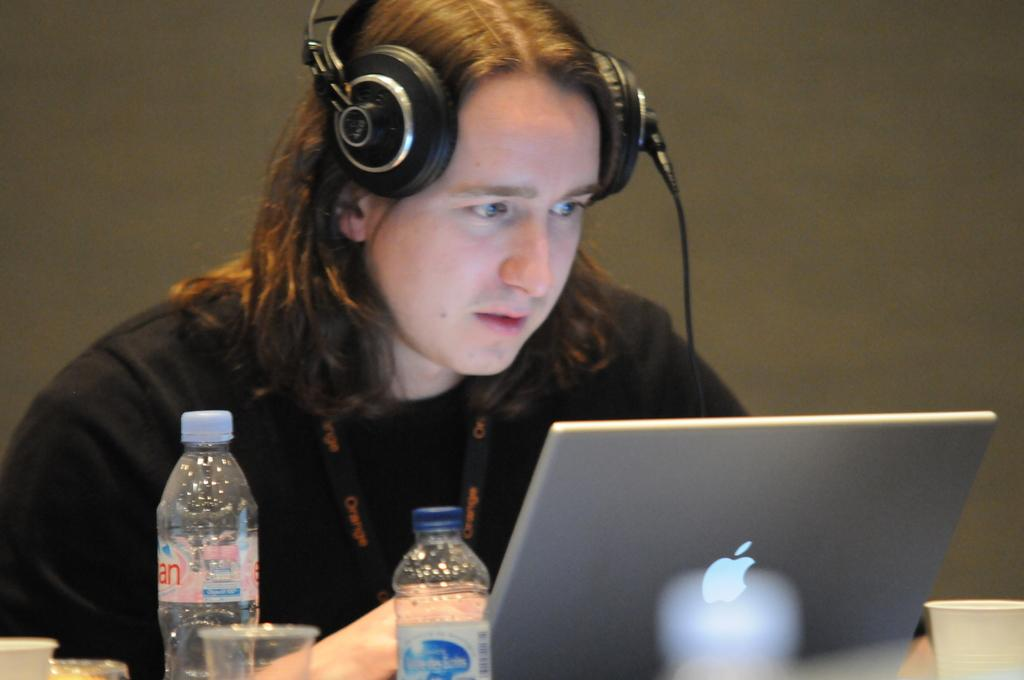Who is in the image? There is a man in the image. What is the man wearing? The man is wearing a black shirt. What is the man doing in the image? The man is putting on a headset. What electronic device is visible in the image? There is a laptop in the image. What items are placed on the laptop? A paper cup, a water bottle, and a plastic glass are present on the laptop. What type of yak can be seen in the image? There is no yak present in the image. What type of lace is used to decorate the man's shirt in the image? The man's shirt is a solid black color, and there is no lace visible on it. 